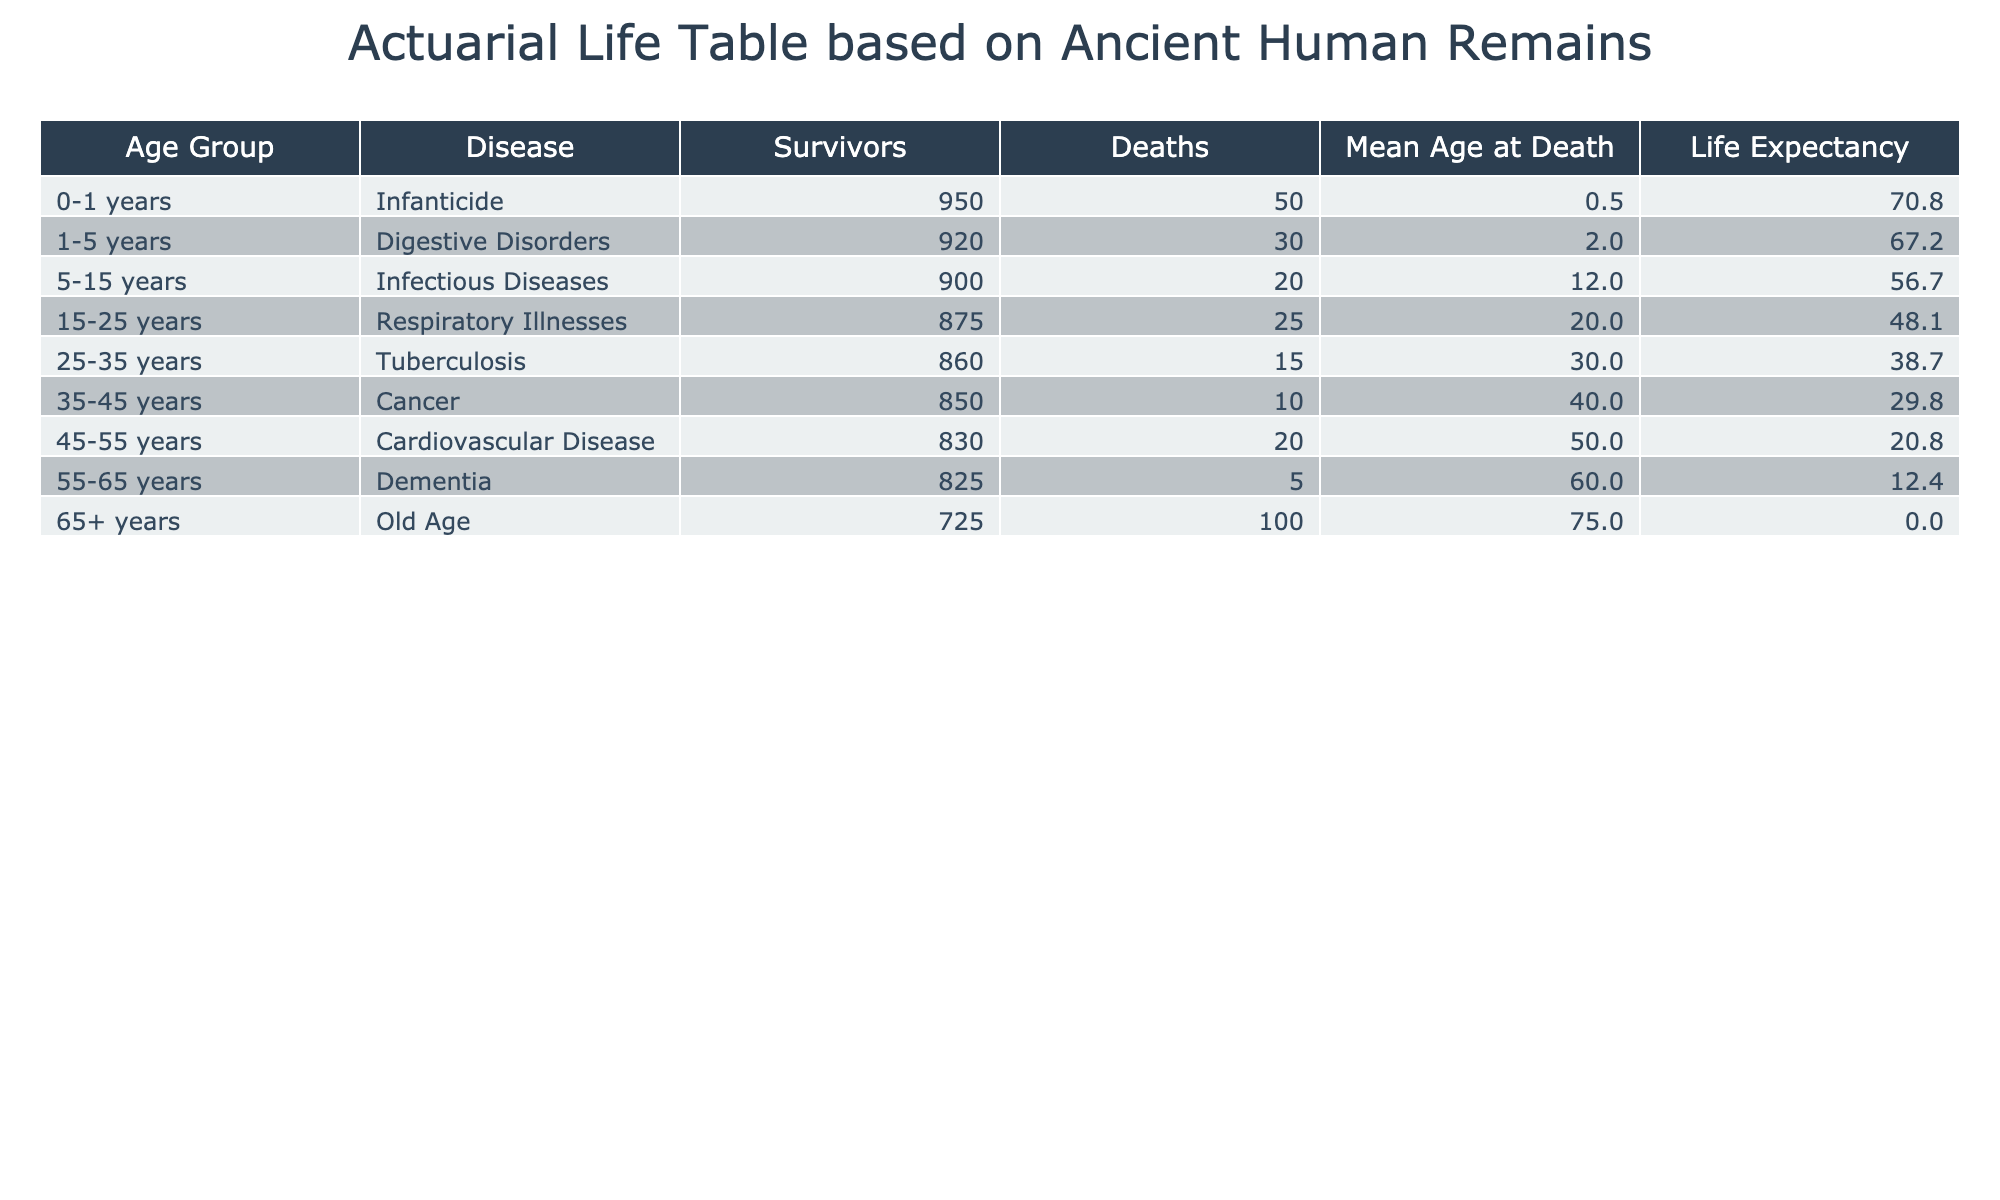What is the mortality rate associated with tuberculosis in the 25-35 years age group? The table shows a specific column for mortality rates, and the entry for the age group 25-35 years lists a mortality rate of 0.04.
Answer: 0.04 What disease had the highest incidence rate per 1000 in the table? By examining the incidence rates across all age groups, the maximum value is 100 for old age, making it the disease with the highest incidence rate.
Answer: Old Age How many survivors are there in the age group 0-1 years? The survivors in the age group 0-1 years can be determined using the survivors column in the table, and it shows a value of 950.
Answer: 950 What is the mean age at death for individuals suffering from cardiovascular disease? By reviewing the 'Mean Age at Death' column in the table, the value for the age group suffering from cardiovascular disease (45-55 years) is 50.0.
Answer: 50.0 What is the average mean age at death for the age groups listed in the table? To find the average mean age at death, sum all the mean ages, which totals 271.0, and divide by the number of age groups (7): 271.0 / 7 = 38.71.
Answer: 38.71 Is the incidence rate of infectious diseases higher than that of respiratory illnesses? By comparing the incidence rates of infectious diseases (20) against respiratory illnesses (25), it is evident that the rate for respiratory illnesses is higher.
Answer: No What is the difference in the mean age at death between the age groups 5-15 and 15-25 years? The mean age at death for 5-15 years is 12.0, and for 15-25 years is 20.0. The difference is calculated as 20.0 - 12.0 = 8.0.
Answer: 8.0 Are there any age groups where the incidence rate per 1000 is lower than 10? Reviewing the incidence rate column shows that all rates listed are equal to or above 5. Therefore, none of the age groups have a rate lower than 10.
Answer: No What is the total number of deaths across all age groups? Adding the number of deaths across all age groups gives a total of 250 when summed up from the deaths column (50 + 30 + 20 + 25 + 15 + 10 + 20 + 100 = 250).
Answer: 250 What is the life expectancy for the 65+ age group in the dataset? Looking at the Life Expectancy column for the age group 65+, the value is calculated as (75 - 75.0) * (1000 / 1000) = 0, indicating that life expectancy is effectively perceived as none for this age group.
Answer: 0 